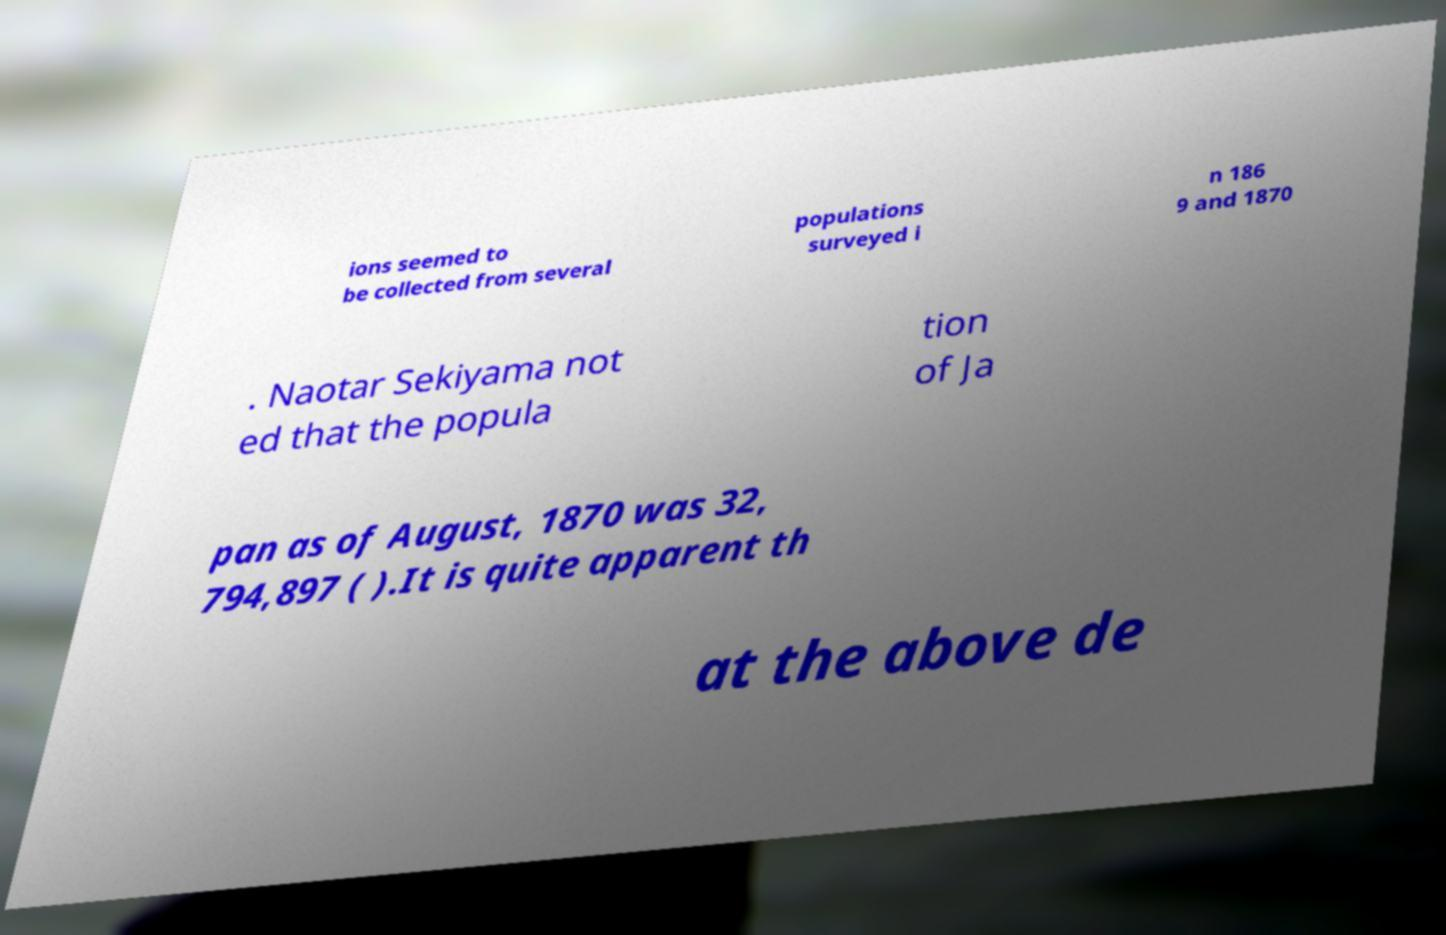Please identify and transcribe the text found in this image. ions seemed to be collected from several populations surveyed i n 186 9 and 1870 . Naotar Sekiyama not ed that the popula tion of Ja pan as of August, 1870 was 32, 794,897 ( ).It is quite apparent th at the above de 